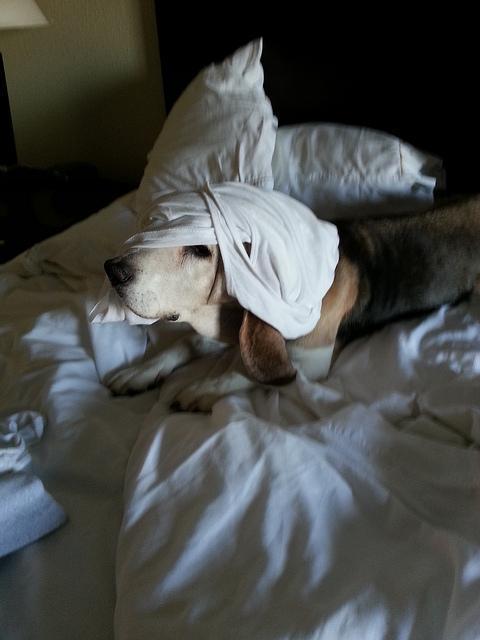How many beds are there?
Give a very brief answer. 1. 